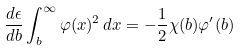Convert formula to latex. <formula><loc_0><loc_0><loc_500><loc_500>\frac { d \epsilon } { d b } \int _ { b } ^ { \infty } \varphi ( x ) ^ { 2 } \, d x = - \frac { 1 } { 2 } \chi ( b ) \varphi ^ { \prime } ( b )</formula> 